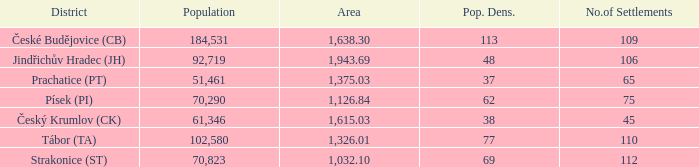How big is the area that has a population density of 113 and a population larger than 184,531? 0.0. 